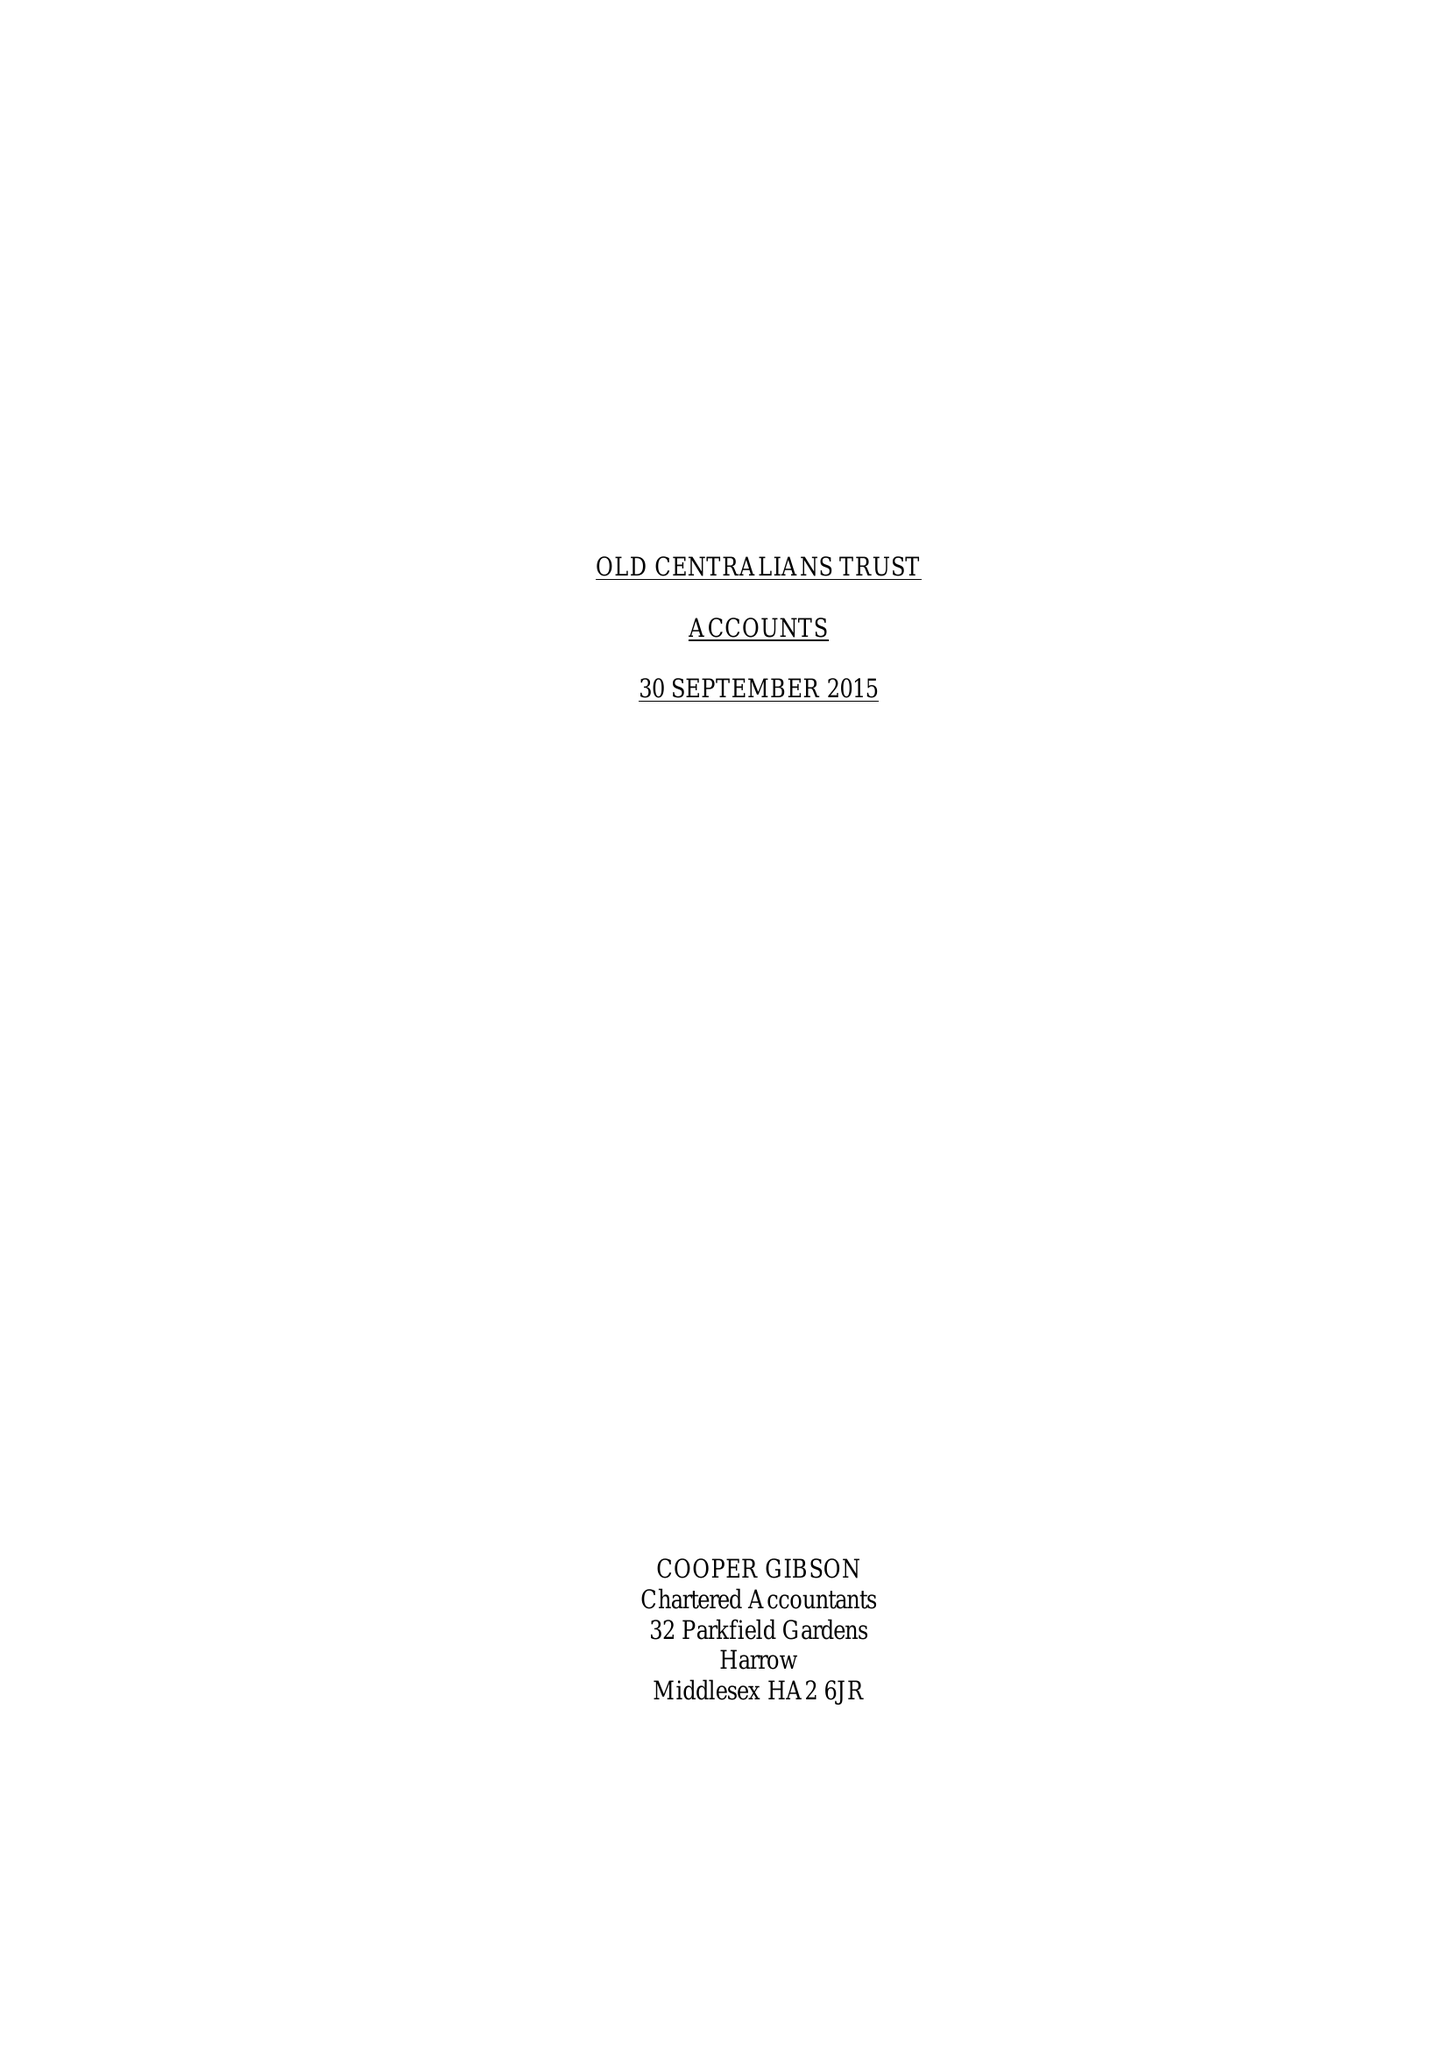What is the value for the income_annually_in_british_pounds?
Answer the question using a single word or phrase. 66933.00 